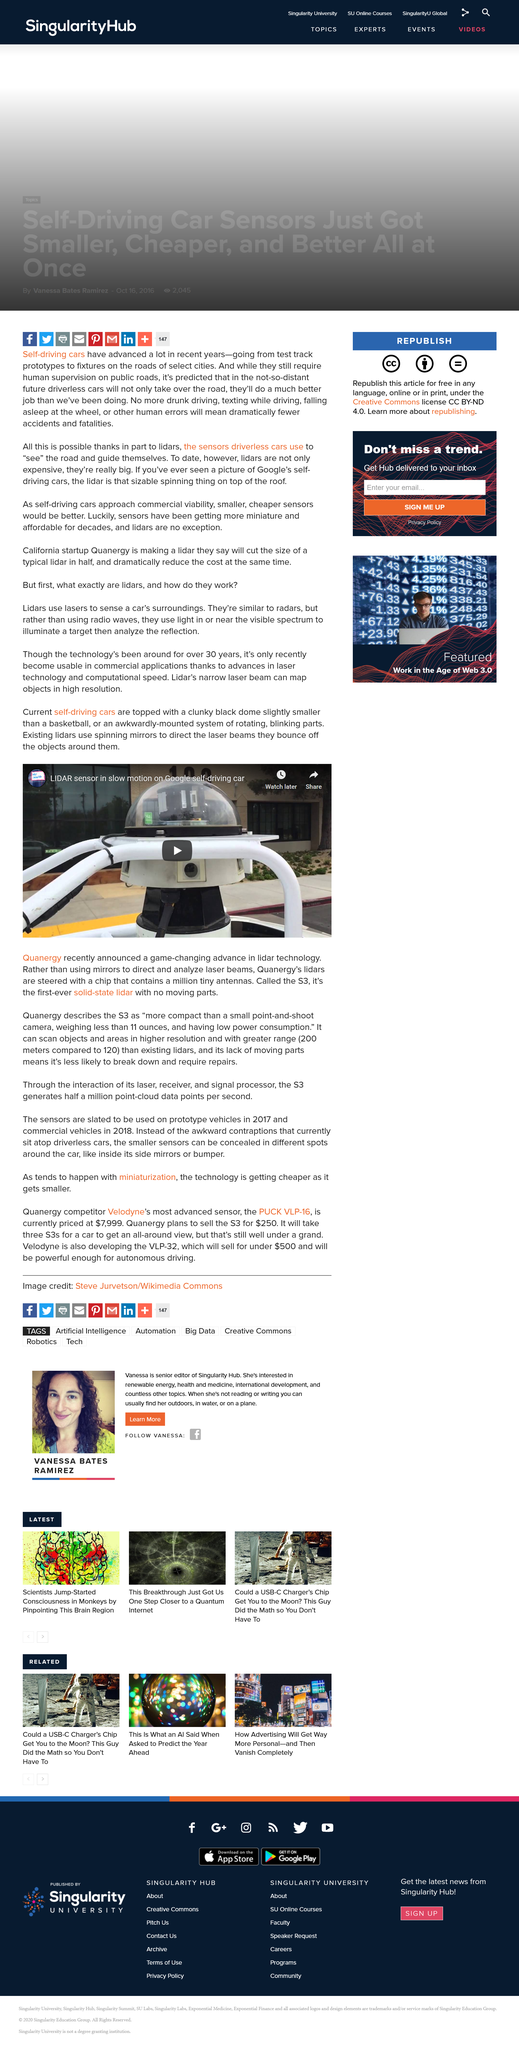Highlight a few significant elements in this photo. Quanergy's solid-state lidar is significantly smaller than existing lidars, which are large, mounted systems of rotating parts topped with a dome slightly bigger than a basketball. In comparison, Quanergy's solid-state lidar is more compact than a small point-and-shoot camera, making it more convenient and portable for various applications. Quanergy's lidar is truly revolutionary, as it is the first-ever device of its kind to feature no moving parts whatsoever. This groundbreaking innovation sets it apart from all other lidars on the market, making it the go-to choice for those seeking the highest quality and reliability in their sensing technology. Quanergy's solid-state lidar is capable of scanning objects up to 80 meters farther than existing lidars, making it a superior choice for a wide range of applications. 